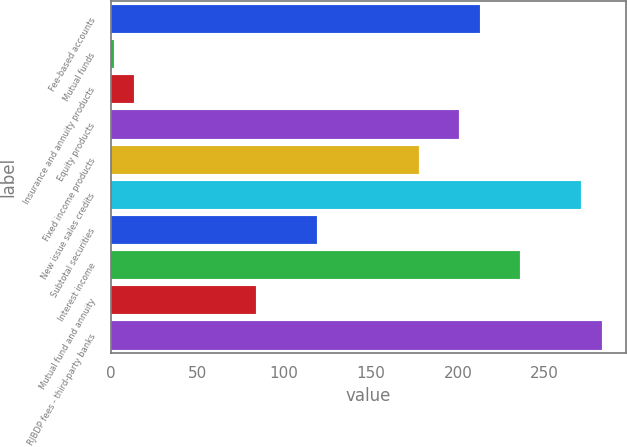Convert chart to OTSL. <chart><loc_0><loc_0><loc_500><loc_500><bar_chart><fcel>Fee-based accounts<fcel>Mutual funds<fcel>Insurance and annuity products<fcel>Equity products<fcel>Fixed income products<fcel>New issue sales credits<fcel>Subtotal securities<fcel>Interest income<fcel>Mutual fund and annuity<fcel>RJBDP fees - third-party banks<nl><fcel>212.6<fcel>2<fcel>13.7<fcel>200.9<fcel>177.5<fcel>271.1<fcel>119<fcel>236<fcel>83.9<fcel>282.8<nl></chart> 